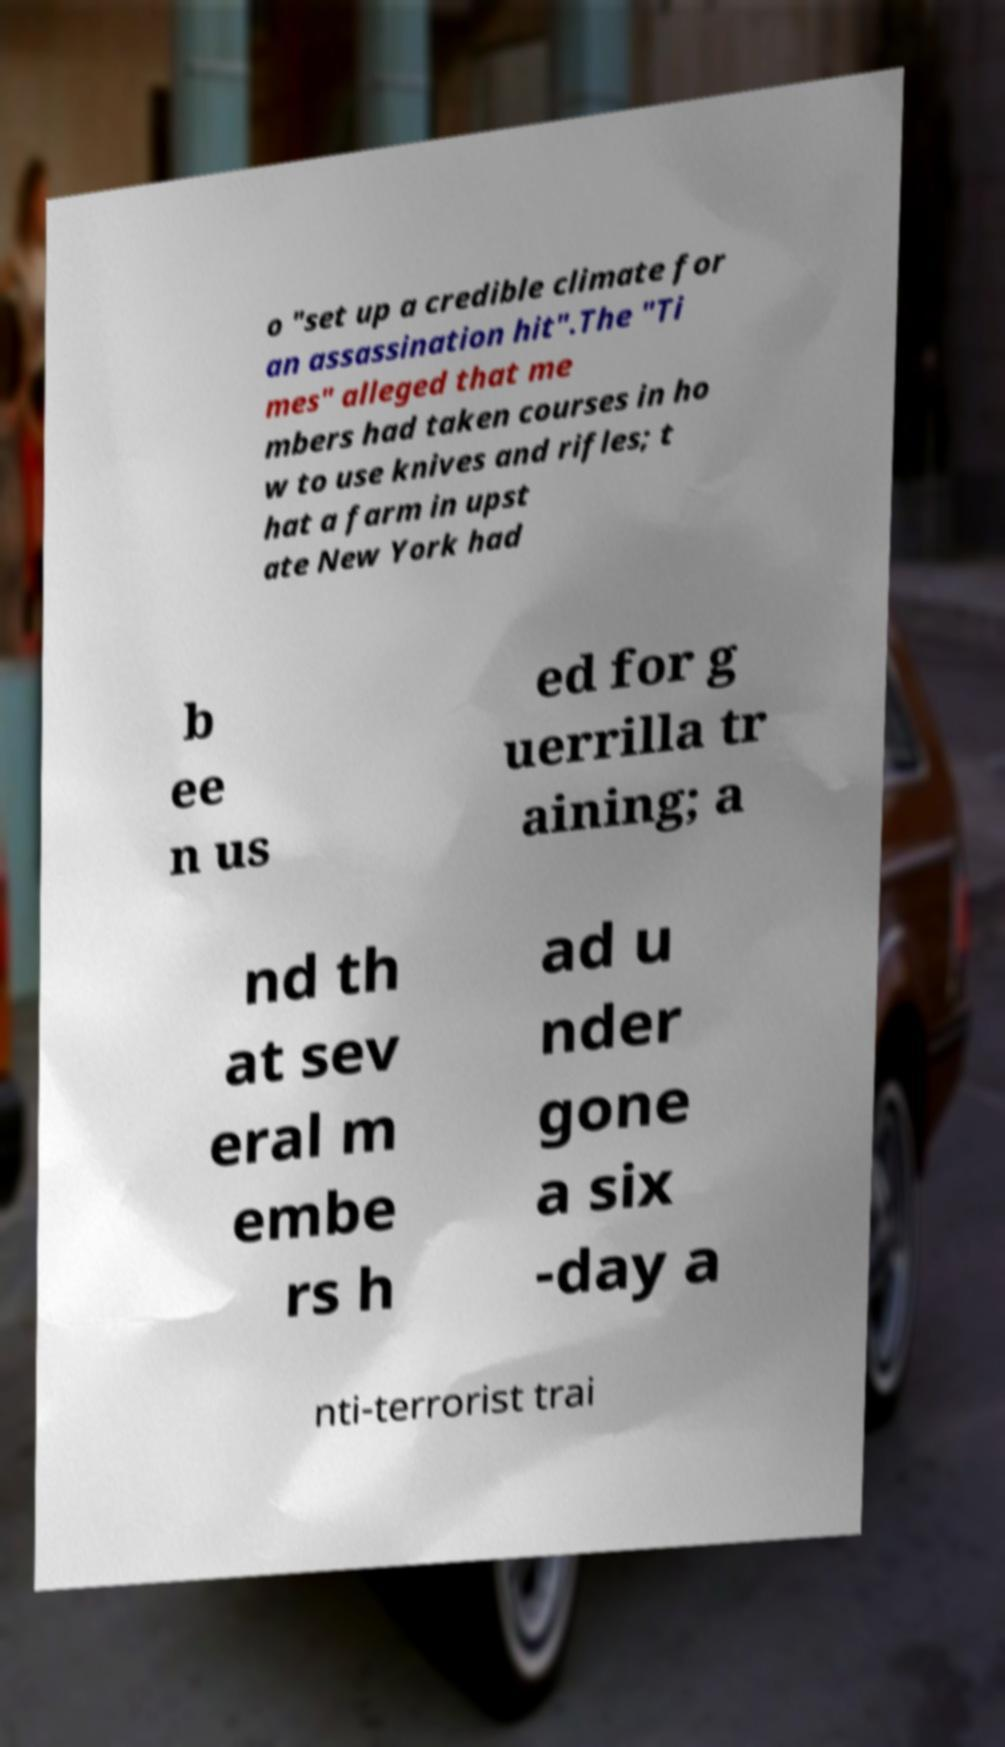Please read and relay the text visible in this image. What does it say? o "set up a credible climate for an assassination hit".The "Ti mes" alleged that me mbers had taken courses in ho w to use knives and rifles; t hat a farm in upst ate New York had b ee n us ed for g uerrilla tr aining; a nd th at sev eral m embe rs h ad u nder gone a six -day a nti-terrorist trai 